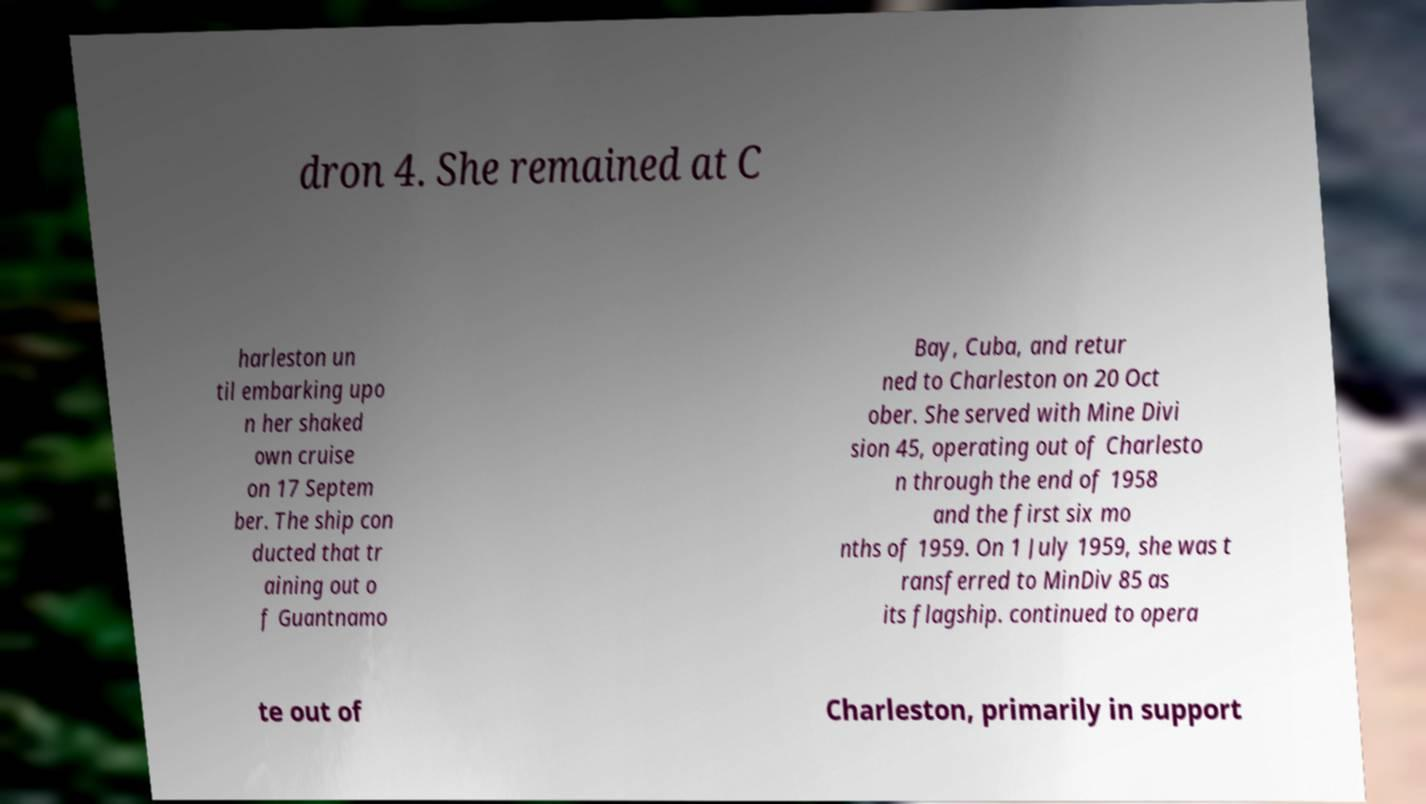Please identify and transcribe the text found in this image. dron 4. She remained at C harleston un til embarking upo n her shaked own cruise on 17 Septem ber. The ship con ducted that tr aining out o f Guantnamo Bay, Cuba, and retur ned to Charleston on 20 Oct ober. She served with Mine Divi sion 45, operating out of Charlesto n through the end of 1958 and the first six mo nths of 1959. On 1 July 1959, she was t ransferred to MinDiv 85 as its flagship. continued to opera te out of Charleston, primarily in support 